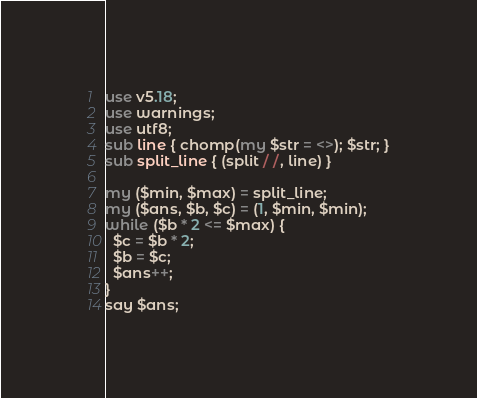<code> <loc_0><loc_0><loc_500><loc_500><_Perl_>use v5.18;
use warnings;
use utf8;
sub line { chomp(my $str = <>); $str; }
sub split_line { (split / /, line) }

my ($min, $max) = split_line;
my ($ans, $b, $c) = (1, $min, $min);
while ($b * 2 <= $max) {
  $c = $b * 2;
  $b = $c;
  $ans++;
}
say $ans;
</code> 